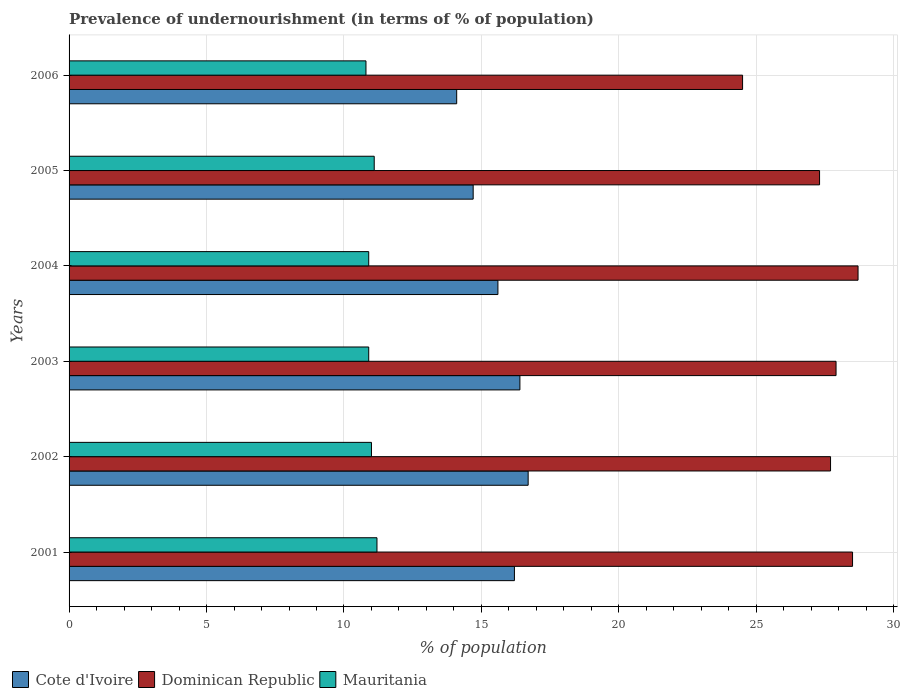How many different coloured bars are there?
Your response must be concise. 3. Are the number of bars on each tick of the Y-axis equal?
Offer a terse response. Yes. How many bars are there on the 6th tick from the top?
Give a very brief answer. 3. How many bars are there on the 2nd tick from the bottom?
Provide a succinct answer. 3. What is the label of the 2nd group of bars from the top?
Give a very brief answer. 2005. In how many cases, is the number of bars for a given year not equal to the number of legend labels?
Provide a succinct answer. 0. Across all years, what is the maximum percentage of undernourished population in Cote d'Ivoire?
Offer a very short reply. 16.7. In which year was the percentage of undernourished population in Dominican Republic minimum?
Provide a short and direct response. 2006. What is the total percentage of undernourished population in Mauritania in the graph?
Provide a succinct answer. 65.9. What is the difference between the percentage of undernourished population in Cote d'Ivoire in 2001 and that in 2005?
Your answer should be compact. 1.5. What is the average percentage of undernourished population in Cote d'Ivoire per year?
Ensure brevity in your answer.  15.62. In the year 2004, what is the difference between the percentage of undernourished population in Dominican Republic and percentage of undernourished population in Mauritania?
Keep it short and to the point. 17.8. In how many years, is the percentage of undernourished population in Cote d'Ivoire greater than 1 %?
Keep it short and to the point. 6. What is the ratio of the percentage of undernourished population in Mauritania in 2004 to that in 2006?
Offer a very short reply. 1.01. Is the difference between the percentage of undernourished population in Dominican Republic in 2002 and 2006 greater than the difference between the percentage of undernourished population in Mauritania in 2002 and 2006?
Offer a terse response. Yes. What is the difference between the highest and the second highest percentage of undernourished population in Mauritania?
Your answer should be very brief. 0.1. What is the difference between the highest and the lowest percentage of undernourished population in Dominican Republic?
Your answer should be very brief. 4.2. In how many years, is the percentage of undernourished population in Dominican Republic greater than the average percentage of undernourished population in Dominican Republic taken over all years?
Provide a succinct answer. 4. Is the sum of the percentage of undernourished population in Mauritania in 2002 and 2006 greater than the maximum percentage of undernourished population in Dominican Republic across all years?
Offer a very short reply. No. What does the 1st bar from the top in 2006 represents?
Ensure brevity in your answer.  Mauritania. What does the 1st bar from the bottom in 2006 represents?
Provide a short and direct response. Cote d'Ivoire. Are the values on the major ticks of X-axis written in scientific E-notation?
Give a very brief answer. No. Does the graph contain any zero values?
Offer a very short reply. No. Where does the legend appear in the graph?
Make the answer very short. Bottom left. How many legend labels are there?
Provide a short and direct response. 3. What is the title of the graph?
Offer a very short reply. Prevalence of undernourishment (in terms of % of population). Does "Somalia" appear as one of the legend labels in the graph?
Your answer should be very brief. No. What is the label or title of the X-axis?
Your answer should be compact. % of population. What is the % of population in Cote d'Ivoire in 2001?
Your answer should be compact. 16.2. What is the % of population of Dominican Republic in 2002?
Give a very brief answer. 27.7. What is the % of population of Cote d'Ivoire in 2003?
Ensure brevity in your answer.  16.4. What is the % of population of Dominican Republic in 2003?
Give a very brief answer. 27.9. What is the % of population of Mauritania in 2003?
Provide a succinct answer. 10.9. What is the % of population of Cote d'Ivoire in 2004?
Your answer should be compact. 15.6. What is the % of population in Dominican Republic in 2004?
Make the answer very short. 28.7. What is the % of population of Mauritania in 2004?
Offer a terse response. 10.9. What is the % of population of Dominican Republic in 2005?
Offer a very short reply. 27.3. What is the % of population in Mauritania in 2005?
Your answer should be compact. 11.1. What is the % of population of Cote d'Ivoire in 2006?
Make the answer very short. 14.1. What is the % of population in Mauritania in 2006?
Your answer should be very brief. 10.8. Across all years, what is the maximum % of population of Dominican Republic?
Ensure brevity in your answer.  28.7. Across all years, what is the maximum % of population in Mauritania?
Your response must be concise. 11.2. Across all years, what is the minimum % of population of Cote d'Ivoire?
Ensure brevity in your answer.  14.1. Across all years, what is the minimum % of population of Mauritania?
Provide a succinct answer. 10.8. What is the total % of population of Cote d'Ivoire in the graph?
Offer a very short reply. 93.7. What is the total % of population in Dominican Republic in the graph?
Provide a succinct answer. 164.6. What is the total % of population of Mauritania in the graph?
Provide a short and direct response. 65.9. What is the difference between the % of population of Dominican Republic in 2001 and that in 2002?
Ensure brevity in your answer.  0.8. What is the difference between the % of population of Mauritania in 2001 and that in 2002?
Provide a short and direct response. 0.2. What is the difference between the % of population in Cote d'Ivoire in 2001 and that in 2003?
Your response must be concise. -0.2. What is the difference between the % of population of Dominican Republic in 2001 and that in 2003?
Your answer should be very brief. 0.6. What is the difference between the % of population in Mauritania in 2001 and that in 2003?
Provide a succinct answer. 0.3. What is the difference between the % of population of Dominican Republic in 2001 and that in 2004?
Your response must be concise. -0.2. What is the difference between the % of population of Cote d'Ivoire in 2001 and that in 2005?
Offer a very short reply. 1.5. What is the difference between the % of population in Dominican Republic in 2001 and that in 2005?
Ensure brevity in your answer.  1.2. What is the difference between the % of population in Cote d'Ivoire in 2001 and that in 2006?
Offer a very short reply. 2.1. What is the difference between the % of population of Dominican Republic in 2001 and that in 2006?
Ensure brevity in your answer.  4. What is the difference between the % of population in Dominican Republic in 2002 and that in 2003?
Give a very brief answer. -0.2. What is the difference between the % of population in Mauritania in 2002 and that in 2004?
Ensure brevity in your answer.  0.1. What is the difference between the % of population of Dominican Republic in 2002 and that in 2005?
Your answer should be compact. 0.4. What is the difference between the % of population in Mauritania in 2002 and that in 2005?
Make the answer very short. -0.1. What is the difference between the % of population of Cote d'Ivoire in 2002 and that in 2006?
Give a very brief answer. 2.6. What is the difference between the % of population of Mauritania in 2002 and that in 2006?
Make the answer very short. 0.2. What is the difference between the % of population of Cote d'Ivoire in 2003 and that in 2004?
Give a very brief answer. 0.8. What is the difference between the % of population in Dominican Republic in 2003 and that in 2006?
Provide a short and direct response. 3.4. What is the difference between the % of population of Mauritania in 2003 and that in 2006?
Ensure brevity in your answer.  0.1. What is the difference between the % of population of Mauritania in 2004 and that in 2005?
Ensure brevity in your answer.  -0.2. What is the difference between the % of population of Dominican Republic in 2004 and that in 2006?
Offer a terse response. 4.2. What is the difference between the % of population in Cote d'Ivoire in 2005 and that in 2006?
Your response must be concise. 0.6. What is the difference between the % of population in Dominican Republic in 2005 and that in 2006?
Your response must be concise. 2.8. What is the difference between the % of population of Cote d'Ivoire in 2001 and the % of population of Dominican Republic in 2002?
Provide a short and direct response. -11.5. What is the difference between the % of population in Dominican Republic in 2001 and the % of population in Mauritania in 2002?
Offer a very short reply. 17.5. What is the difference between the % of population in Cote d'Ivoire in 2001 and the % of population in Dominican Republic in 2003?
Make the answer very short. -11.7. What is the difference between the % of population of Dominican Republic in 2001 and the % of population of Mauritania in 2003?
Provide a succinct answer. 17.6. What is the difference between the % of population of Cote d'Ivoire in 2001 and the % of population of Dominican Republic in 2004?
Offer a very short reply. -12.5. What is the difference between the % of population in Cote d'Ivoire in 2001 and the % of population in Mauritania in 2004?
Provide a succinct answer. 5.3. What is the difference between the % of population of Dominican Republic in 2001 and the % of population of Mauritania in 2004?
Provide a succinct answer. 17.6. What is the difference between the % of population in Cote d'Ivoire in 2001 and the % of population in Dominican Republic in 2005?
Ensure brevity in your answer.  -11.1. What is the difference between the % of population in Dominican Republic in 2001 and the % of population in Mauritania in 2005?
Provide a short and direct response. 17.4. What is the difference between the % of population in Cote d'Ivoire in 2001 and the % of population in Dominican Republic in 2006?
Your response must be concise. -8.3. What is the difference between the % of population of Cote d'Ivoire in 2001 and the % of population of Mauritania in 2006?
Your answer should be very brief. 5.4. What is the difference between the % of population in Cote d'Ivoire in 2002 and the % of population in Mauritania in 2003?
Your answer should be compact. 5.8. What is the difference between the % of population in Dominican Republic in 2002 and the % of population in Mauritania in 2003?
Your answer should be very brief. 16.8. What is the difference between the % of population of Cote d'Ivoire in 2002 and the % of population of Mauritania in 2004?
Make the answer very short. 5.8. What is the difference between the % of population in Cote d'Ivoire in 2002 and the % of population in Mauritania in 2005?
Keep it short and to the point. 5.6. What is the difference between the % of population in Dominican Republic in 2002 and the % of population in Mauritania in 2005?
Offer a very short reply. 16.6. What is the difference between the % of population of Cote d'Ivoire in 2003 and the % of population of Mauritania in 2004?
Your answer should be very brief. 5.5. What is the difference between the % of population in Dominican Republic in 2003 and the % of population in Mauritania in 2004?
Your response must be concise. 17. What is the difference between the % of population in Cote d'Ivoire in 2003 and the % of population in Mauritania in 2005?
Your answer should be very brief. 5.3. What is the difference between the % of population in Dominican Republic in 2003 and the % of population in Mauritania in 2006?
Offer a very short reply. 17.1. What is the difference between the % of population of Cote d'Ivoire in 2004 and the % of population of Dominican Republic in 2005?
Ensure brevity in your answer.  -11.7. What is the difference between the % of population of Dominican Republic in 2004 and the % of population of Mauritania in 2005?
Provide a succinct answer. 17.6. What is the difference between the % of population in Cote d'Ivoire in 2004 and the % of population in Dominican Republic in 2006?
Provide a succinct answer. -8.9. What is the difference between the % of population of Cote d'Ivoire in 2004 and the % of population of Mauritania in 2006?
Keep it short and to the point. 4.8. What is the difference between the % of population in Dominican Republic in 2004 and the % of population in Mauritania in 2006?
Your answer should be very brief. 17.9. What is the difference between the % of population in Cote d'Ivoire in 2005 and the % of population in Mauritania in 2006?
Make the answer very short. 3.9. What is the average % of population in Cote d'Ivoire per year?
Offer a terse response. 15.62. What is the average % of population in Dominican Republic per year?
Provide a succinct answer. 27.43. What is the average % of population in Mauritania per year?
Your response must be concise. 10.98. In the year 2001, what is the difference between the % of population in Dominican Republic and % of population in Mauritania?
Ensure brevity in your answer.  17.3. In the year 2002, what is the difference between the % of population in Dominican Republic and % of population in Mauritania?
Offer a terse response. 16.7. In the year 2003, what is the difference between the % of population of Cote d'Ivoire and % of population of Dominican Republic?
Ensure brevity in your answer.  -11.5. In the year 2004, what is the difference between the % of population in Cote d'Ivoire and % of population in Mauritania?
Offer a very short reply. 4.7. In the year 2004, what is the difference between the % of population of Dominican Republic and % of population of Mauritania?
Your response must be concise. 17.8. In the year 2005, what is the difference between the % of population in Cote d'Ivoire and % of population in Mauritania?
Offer a very short reply. 3.6. In the year 2006, what is the difference between the % of population of Cote d'Ivoire and % of population of Dominican Republic?
Offer a terse response. -10.4. What is the ratio of the % of population in Cote d'Ivoire in 2001 to that in 2002?
Your answer should be very brief. 0.97. What is the ratio of the % of population in Dominican Republic in 2001 to that in 2002?
Make the answer very short. 1.03. What is the ratio of the % of population in Mauritania in 2001 to that in 2002?
Keep it short and to the point. 1.02. What is the ratio of the % of population of Dominican Republic in 2001 to that in 2003?
Your answer should be very brief. 1.02. What is the ratio of the % of population of Mauritania in 2001 to that in 2003?
Offer a very short reply. 1.03. What is the ratio of the % of population of Dominican Republic in 2001 to that in 2004?
Offer a terse response. 0.99. What is the ratio of the % of population of Mauritania in 2001 to that in 2004?
Make the answer very short. 1.03. What is the ratio of the % of population in Cote d'Ivoire in 2001 to that in 2005?
Offer a terse response. 1.1. What is the ratio of the % of population in Dominican Republic in 2001 to that in 2005?
Keep it short and to the point. 1.04. What is the ratio of the % of population in Mauritania in 2001 to that in 2005?
Keep it short and to the point. 1.01. What is the ratio of the % of population in Cote d'Ivoire in 2001 to that in 2006?
Make the answer very short. 1.15. What is the ratio of the % of population of Dominican Republic in 2001 to that in 2006?
Ensure brevity in your answer.  1.16. What is the ratio of the % of population of Mauritania in 2001 to that in 2006?
Give a very brief answer. 1.04. What is the ratio of the % of population in Cote d'Ivoire in 2002 to that in 2003?
Keep it short and to the point. 1.02. What is the ratio of the % of population of Dominican Republic in 2002 to that in 2003?
Make the answer very short. 0.99. What is the ratio of the % of population in Mauritania in 2002 to that in 2003?
Keep it short and to the point. 1.01. What is the ratio of the % of population in Cote d'Ivoire in 2002 to that in 2004?
Provide a short and direct response. 1.07. What is the ratio of the % of population of Dominican Republic in 2002 to that in 2004?
Give a very brief answer. 0.97. What is the ratio of the % of population of Mauritania in 2002 to that in 2004?
Provide a succinct answer. 1.01. What is the ratio of the % of population in Cote d'Ivoire in 2002 to that in 2005?
Provide a succinct answer. 1.14. What is the ratio of the % of population of Dominican Republic in 2002 to that in 2005?
Your response must be concise. 1.01. What is the ratio of the % of population in Cote d'Ivoire in 2002 to that in 2006?
Provide a succinct answer. 1.18. What is the ratio of the % of population in Dominican Republic in 2002 to that in 2006?
Keep it short and to the point. 1.13. What is the ratio of the % of population in Mauritania in 2002 to that in 2006?
Provide a short and direct response. 1.02. What is the ratio of the % of population in Cote d'Ivoire in 2003 to that in 2004?
Provide a succinct answer. 1.05. What is the ratio of the % of population in Dominican Republic in 2003 to that in 2004?
Keep it short and to the point. 0.97. What is the ratio of the % of population in Cote d'Ivoire in 2003 to that in 2005?
Provide a succinct answer. 1.12. What is the ratio of the % of population in Cote d'Ivoire in 2003 to that in 2006?
Offer a very short reply. 1.16. What is the ratio of the % of population of Dominican Republic in 2003 to that in 2006?
Your answer should be compact. 1.14. What is the ratio of the % of population in Mauritania in 2003 to that in 2006?
Your answer should be compact. 1.01. What is the ratio of the % of population of Cote d'Ivoire in 2004 to that in 2005?
Your response must be concise. 1.06. What is the ratio of the % of population of Dominican Republic in 2004 to that in 2005?
Keep it short and to the point. 1.05. What is the ratio of the % of population in Mauritania in 2004 to that in 2005?
Provide a succinct answer. 0.98. What is the ratio of the % of population of Cote d'Ivoire in 2004 to that in 2006?
Offer a very short reply. 1.11. What is the ratio of the % of population in Dominican Republic in 2004 to that in 2006?
Provide a succinct answer. 1.17. What is the ratio of the % of population in Mauritania in 2004 to that in 2006?
Provide a succinct answer. 1.01. What is the ratio of the % of population in Cote d'Ivoire in 2005 to that in 2006?
Give a very brief answer. 1.04. What is the ratio of the % of population of Dominican Republic in 2005 to that in 2006?
Your answer should be compact. 1.11. What is the ratio of the % of population in Mauritania in 2005 to that in 2006?
Your answer should be very brief. 1.03. What is the difference between the highest and the second highest % of population in Mauritania?
Your answer should be compact. 0.1. What is the difference between the highest and the lowest % of population in Cote d'Ivoire?
Give a very brief answer. 2.6. What is the difference between the highest and the lowest % of population in Dominican Republic?
Your response must be concise. 4.2. What is the difference between the highest and the lowest % of population of Mauritania?
Give a very brief answer. 0.4. 